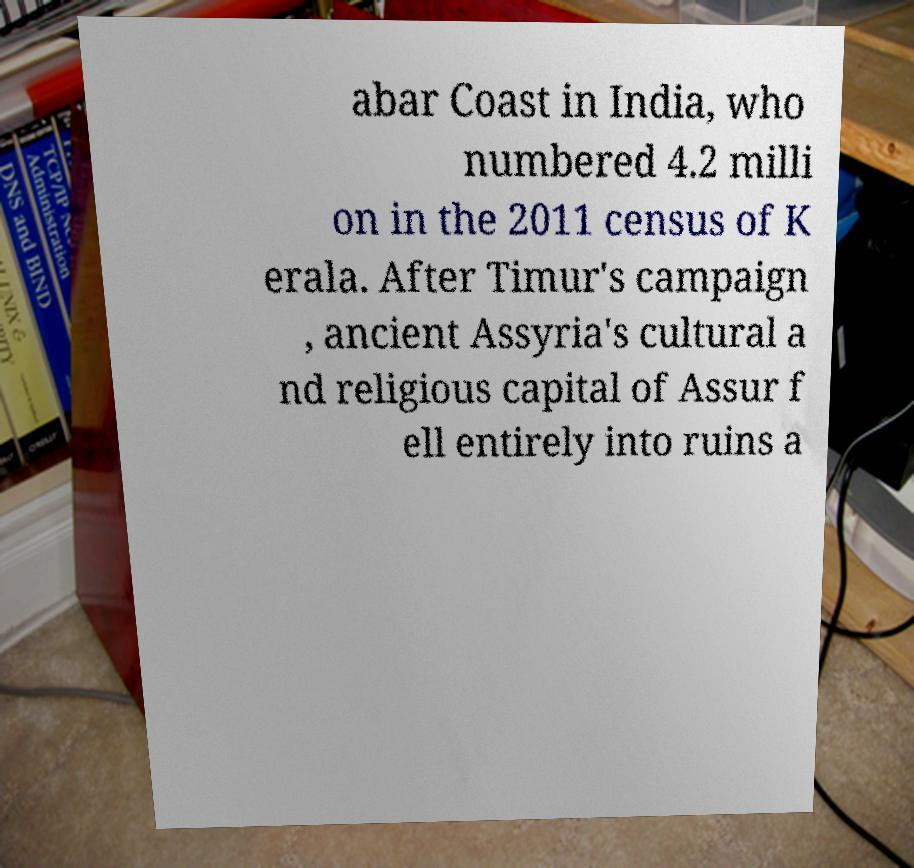Can you accurately transcribe the text from the provided image for me? abar Coast in India, who numbered 4.2 milli on in the 2011 census of K erala. After Timur's campaign , ancient Assyria's cultural a nd religious capital of Assur f ell entirely into ruins a 